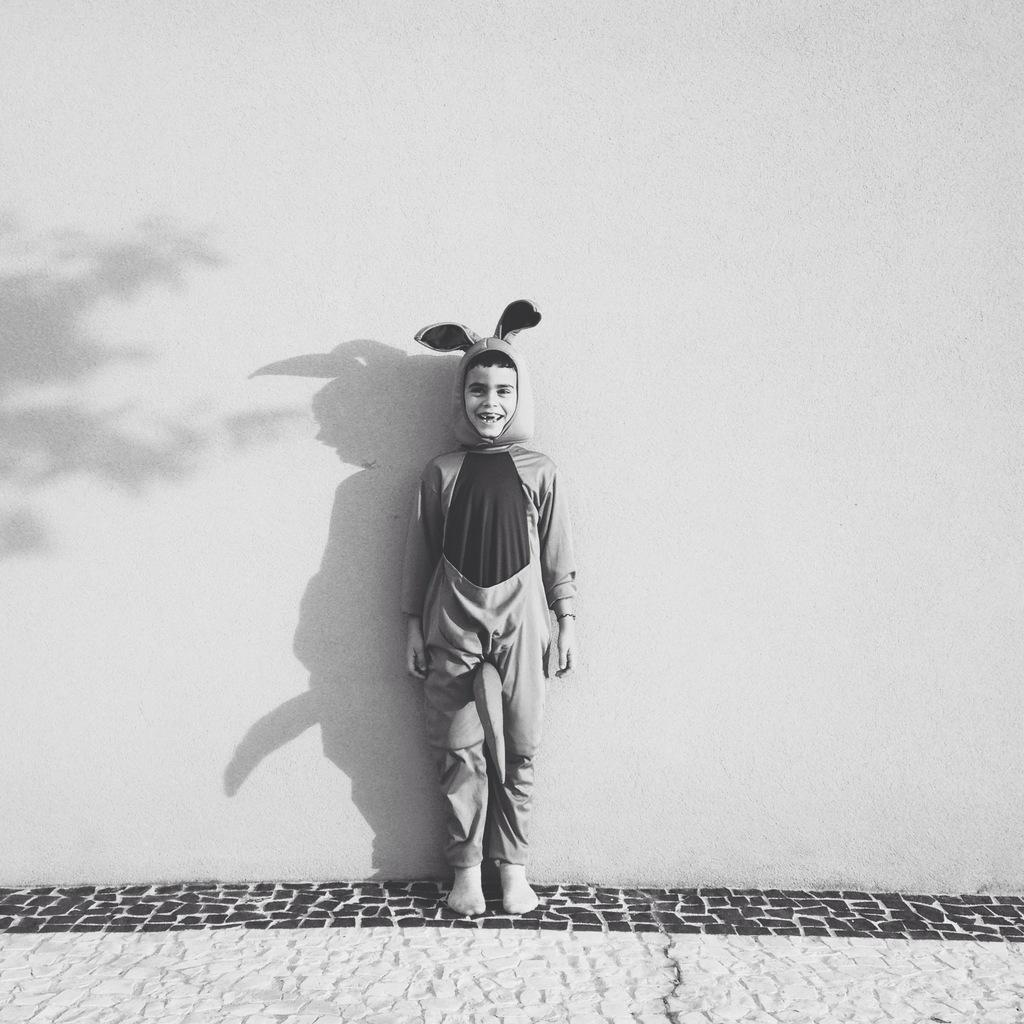What is the main subject of the image? There is a person standing in the image. What is the person wearing? The person is wearing a costume. What can be seen in the background of the image? There is a wall in the background of the image. What is the color scheme of the image? The image is in black and white. How many porters are visible in the image? There are no porters present in the image. What type of ant can be seen crawling on the person's costume? There are no ants visible in the image. 